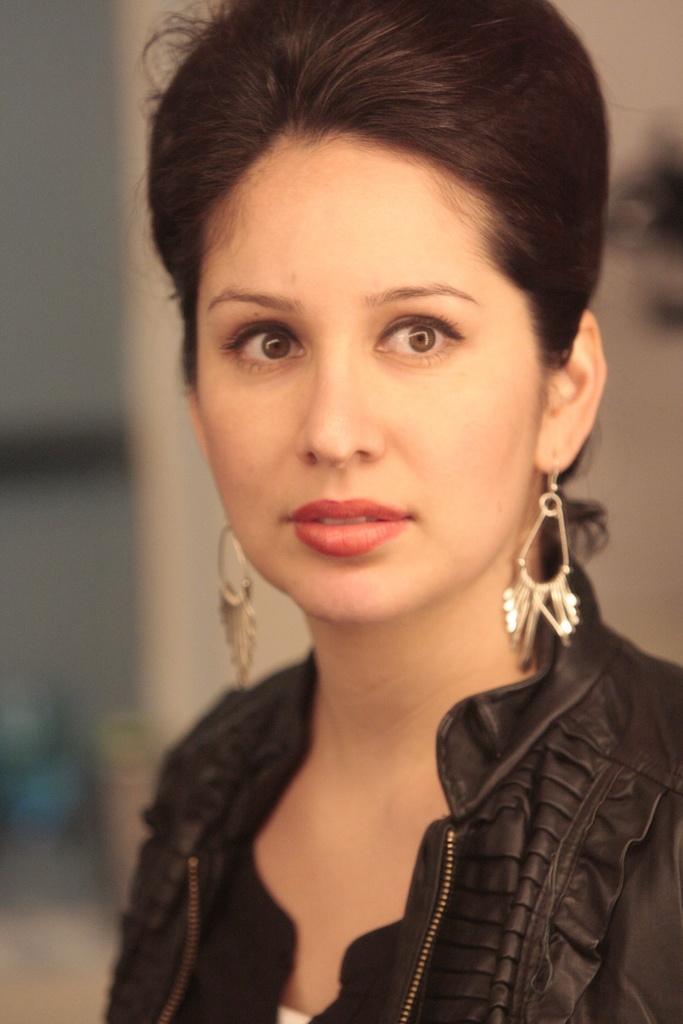In one or two sentences, can you explain what this image depicts? In this picture we can see a woman in the black dress and behind the woman there is a blurred background. 